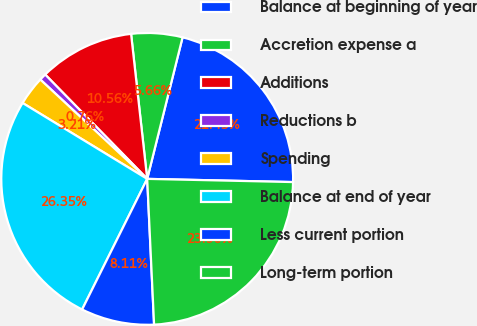<chart> <loc_0><loc_0><loc_500><loc_500><pie_chart><fcel>Balance at beginning of year<fcel>Accretion expense a<fcel>Additions<fcel>Reductions b<fcel>Spending<fcel>Balance at end of year<fcel>Less current portion<fcel>Long-term portion<nl><fcel>21.45%<fcel>5.66%<fcel>10.56%<fcel>0.76%<fcel>3.21%<fcel>26.35%<fcel>8.11%<fcel>23.9%<nl></chart> 